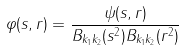Convert formula to latex. <formula><loc_0><loc_0><loc_500><loc_500>\varphi ( s , r ) = \frac { \psi ( s , r ) } { B _ { k _ { 1 } k _ { 2 } } ( s ^ { 2 } ) B _ { k _ { 1 } k _ { 2 } } ( r ^ { 2 } ) }</formula> 